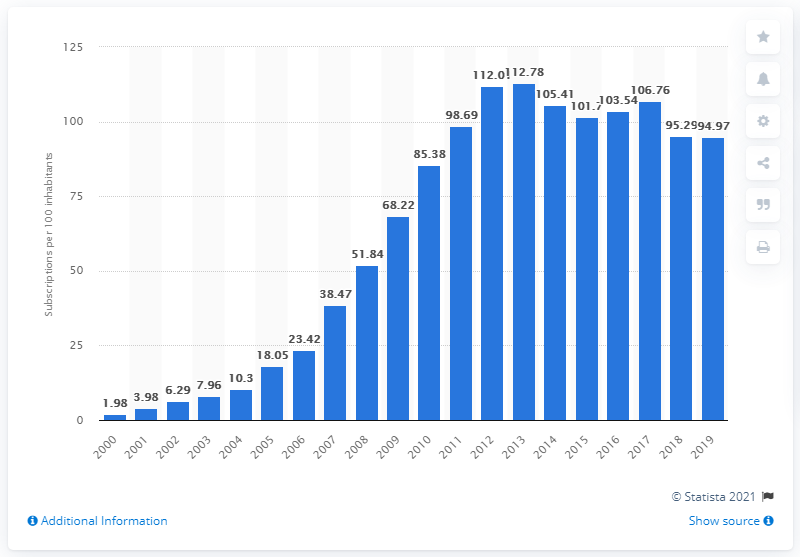Give some essential details in this illustration. In Egypt between 2000 and 2019, an average of 94.97 mobile subscriptions were registered for every 100 people. 